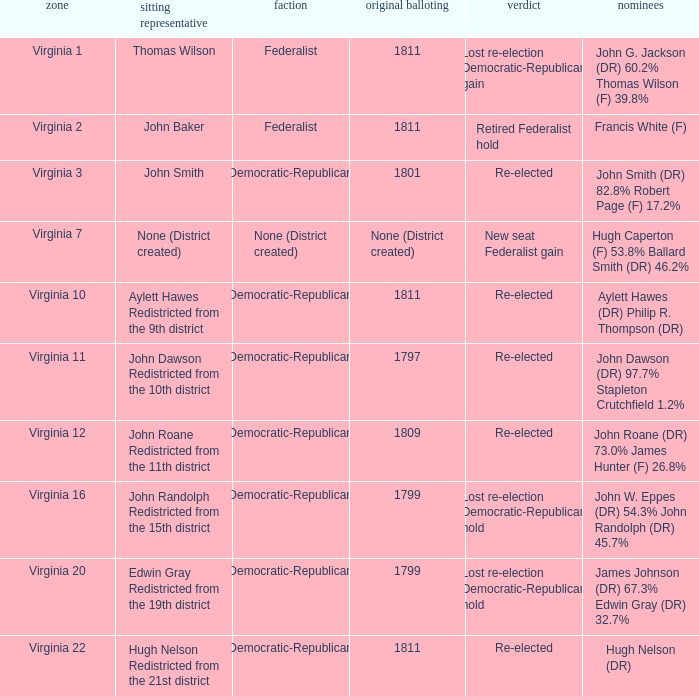Name the party for  john randolph redistricted from the 15th district Democratic-Republican. 